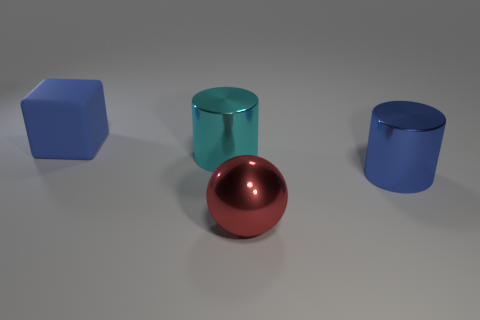Subtract 1 cubes. How many cubes are left? 0 Add 1 big gray metal objects. How many objects exist? 5 Subtract all cubes. How many objects are left? 3 Subtract all blue cylinders. How many cylinders are left? 1 Subtract all brown balls. Subtract all brown cubes. How many balls are left? 1 Subtract all brown blocks. How many blue cylinders are left? 1 Subtract all blocks. Subtract all blue rubber cylinders. How many objects are left? 3 Add 4 cylinders. How many cylinders are left? 6 Add 2 small brown matte cylinders. How many small brown matte cylinders exist? 2 Subtract 0 blue balls. How many objects are left? 4 